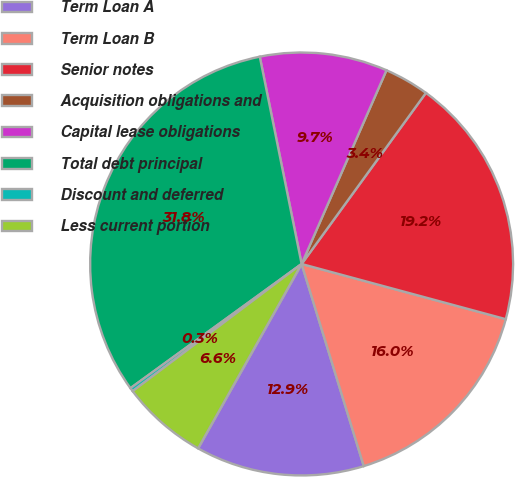<chart> <loc_0><loc_0><loc_500><loc_500><pie_chart><fcel>Term Loan A<fcel>Term Loan B<fcel>Senior notes<fcel>Acquisition obligations and<fcel>Capital lease obligations<fcel>Total debt principal<fcel>Discount and deferred<fcel>Less current portion<nl><fcel>12.89%<fcel>16.05%<fcel>19.2%<fcel>3.43%<fcel>9.74%<fcel>31.82%<fcel>0.28%<fcel>6.59%<nl></chart> 